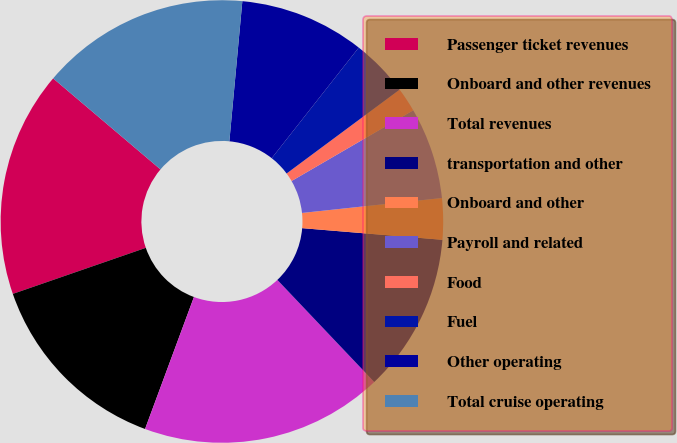Convert chart to OTSL. <chart><loc_0><loc_0><loc_500><loc_500><pie_chart><fcel>Passenger ticket revenues<fcel>Onboard and other revenues<fcel>Total revenues<fcel>transportation and other<fcel>Onboard and other<fcel>Payroll and related<fcel>Food<fcel>Fuel<fcel>Other operating<fcel>Total cruise operating<nl><fcel>16.5%<fcel>14.05%<fcel>17.73%<fcel>11.6%<fcel>3.01%<fcel>6.69%<fcel>1.78%<fcel>4.23%<fcel>9.14%<fcel>15.28%<nl></chart> 